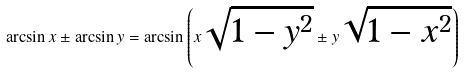<formula> <loc_0><loc_0><loc_500><loc_500>\arcsin x \pm \arcsin y = \arcsin \left ( x { \sqrt { 1 - y ^ { 2 } } } \pm y { \sqrt { 1 - x ^ { 2 } } } \right )</formula> 